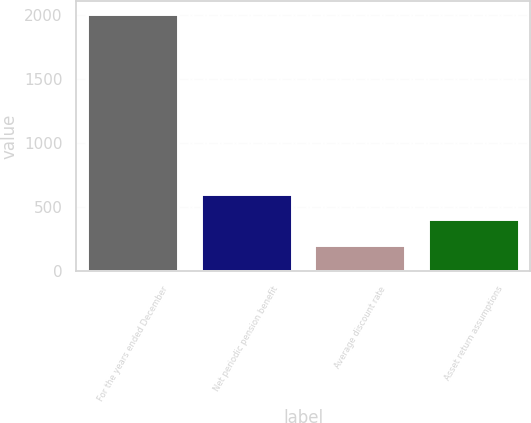Convert chart to OTSL. <chart><loc_0><loc_0><loc_500><loc_500><bar_chart><fcel>For the years ended December<fcel>Net periodic pension benefit<fcel>Average discount rate<fcel>Asset return assumptions<nl><fcel>2008<fcel>606.81<fcel>206.47<fcel>406.64<nl></chart> 